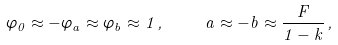Convert formula to latex. <formula><loc_0><loc_0><loc_500><loc_500>\varphi _ { 0 } \approx - \varphi _ { a } \approx \varphi _ { b } \approx 1 \, , \quad a \approx - b \approx \frac { F } { 1 - k } \, ,</formula> 